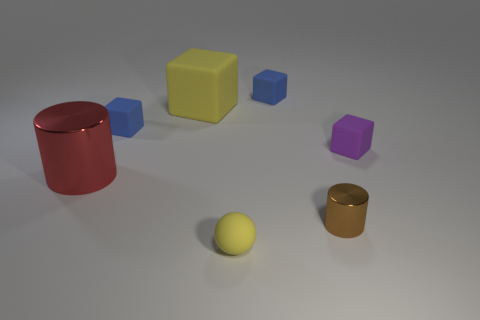How big is the matte block right of the shiny cylinder that is in front of the cylinder on the left side of the brown object?
Your answer should be very brief. Small. How big is the thing that is in front of the purple cube and to the left of the large yellow rubber object?
Your response must be concise. Large. There is a thing behind the big yellow matte thing; does it have the same color as the small block on the left side of the rubber sphere?
Your answer should be very brief. Yes. There is a large yellow object; what number of red metal things are behind it?
Offer a very short reply. 0. Is there a large yellow matte thing that is behind the yellow ball that is left of the shiny thing in front of the red metallic cylinder?
Give a very brief answer. Yes. How many red metal cylinders are the same size as the purple matte block?
Your response must be concise. 0. What is the material of the ball in front of the big object that is in front of the small purple thing?
Provide a short and direct response. Rubber. What shape is the purple matte object right of the yellow thing that is in front of the object that is right of the brown metal cylinder?
Your response must be concise. Cube. Does the large metallic object that is left of the large yellow rubber block have the same shape as the metallic thing to the right of the red thing?
Give a very brief answer. Yes. What number of other objects are the same material as the purple block?
Provide a short and direct response. 4. 